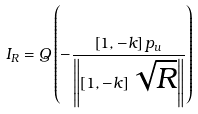<formula> <loc_0><loc_0><loc_500><loc_500>{ I _ { R } } = Q \left ( { - \frac { { \left [ { 1 , - k } \right ] { { p } _ { u } } } } { { \left \| { \left [ { 1 , - k } \right ] \sqrt { R } } \right \| } } } \right )</formula> 